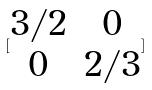<formula> <loc_0><loc_0><loc_500><loc_500>[ \begin{matrix} 3 / 2 & 0 \\ 0 & 2 / 3 \end{matrix} ]</formula> 